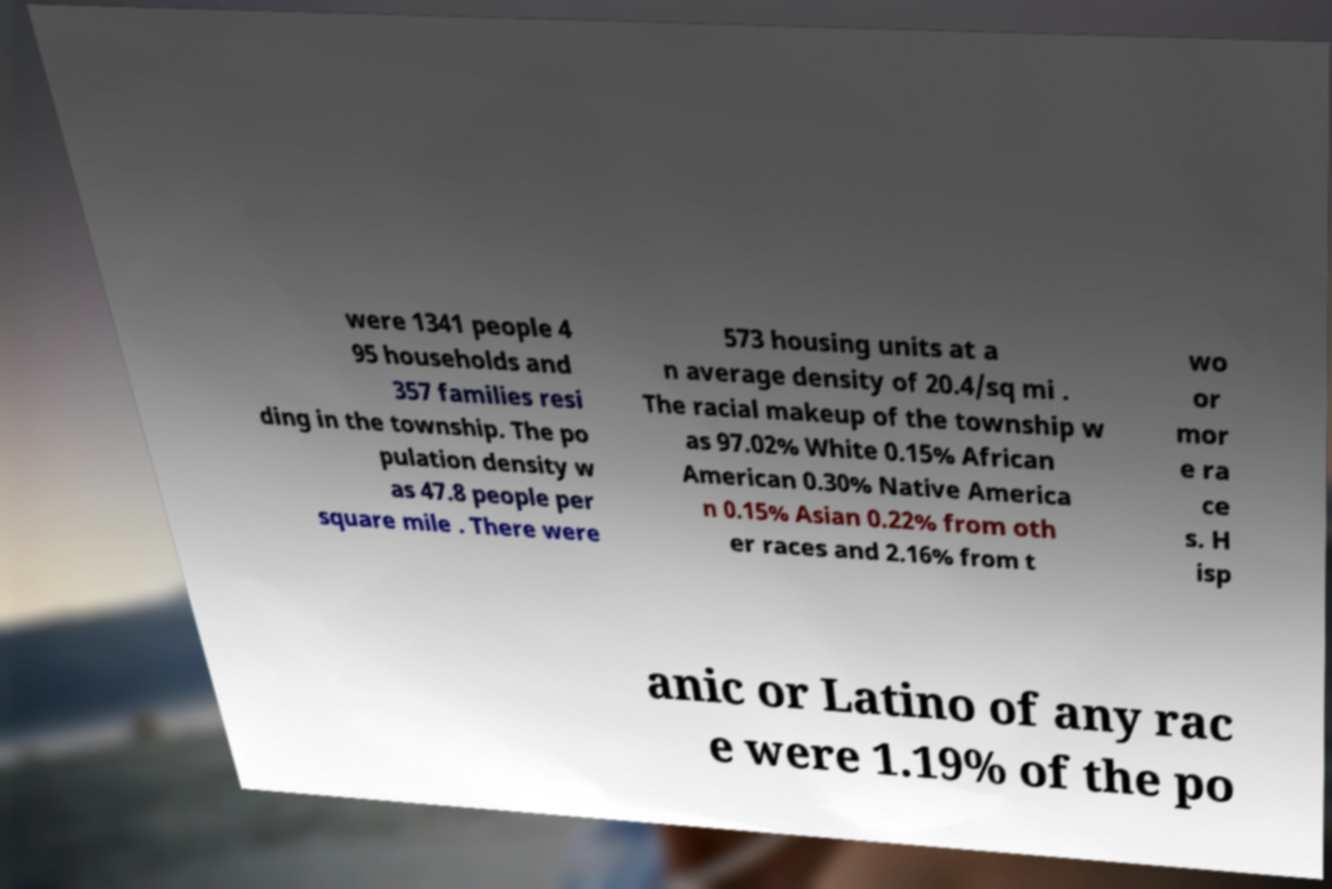Please read and relay the text visible in this image. What does it say? were 1341 people 4 95 households and 357 families resi ding in the township. The po pulation density w as 47.8 people per square mile . There were 573 housing units at a n average density of 20.4/sq mi . The racial makeup of the township w as 97.02% White 0.15% African American 0.30% Native America n 0.15% Asian 0.22% from oth er races and 2.16% from t wo or mor e ra ce s. H isp anic or Latino of any rac e were 1.19% of the po 